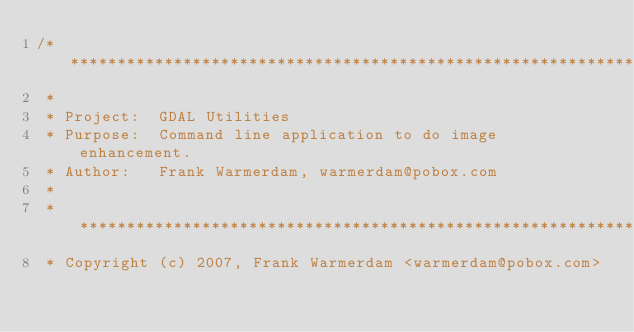<code> <loc_0><loc_0><loc_500><loc_500><_C++_>/******************************************************************************
 *
 * Project:  GDAL Utilities
 * Purpose:  Command line application to do image enhancement.
 * Author:   Frank Warmerdam, warmerdam@pobox.com
 *
 * ****************************************************************************
 * Copyright (c) 2007, Frank Warmerdam <warmerdam@pobox.com></code> 